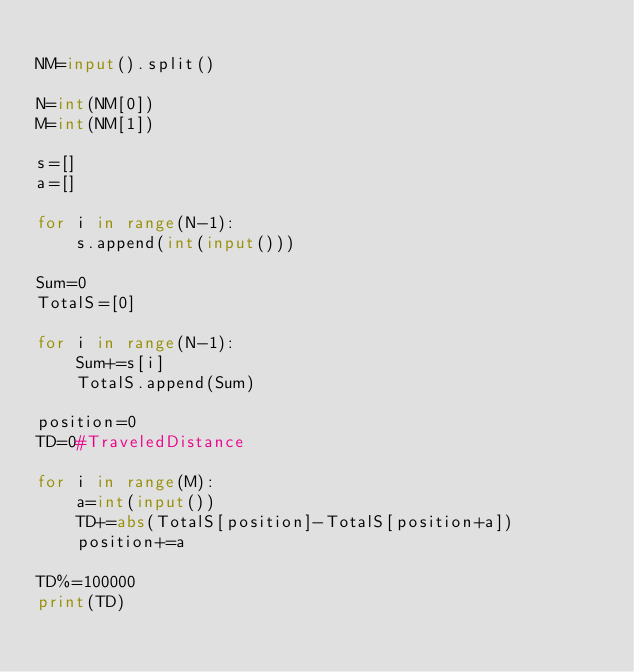Convert code to text. <code><loc_0><loc_0><loc_500><loc_500><_Python_>
NM=input().split()

N=int(NM[0])
M=int(NM[1])

s=[]
a=[]

for i in range(N-1):
    s.append(int(input()))

Sum=0
TotalS=[0]

for i in range(N-1):
    Sum+=s[i]
    TotalS.append(Sum)

position=0
TD=0#TraveledDistance

for i in range(M):
    a=int(input())
    TD+=abs(TotalS[position]-TotalS[position+a])
    position+=a

TD%=100000
print(TD)


</code> 